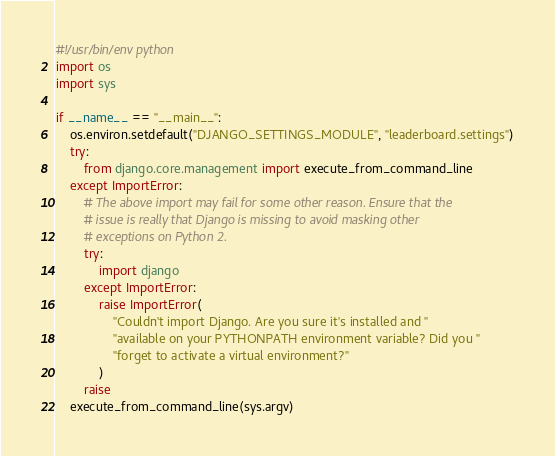<code> <loc_0><loc_0><loc_500><loc_500><_Python_>#!/usr/bin/env python
import os
import sys

if __name__ == "__main__":
    os.environ.setdefault("DJANGO_SETTINGS_MODULE", "leaderboard.settings")
    try:
        from django.core.management import execute_from_command_line
    except ImportError:
        # The above import may fail for some other reason. Ensure that the
        # issue is really that Django is missing to avoid masking other
        # exceptions on Python 2.
        try:
            import django
        except ImportError:
            raise ImportError(
                "Couldn't import Django. Are you sure it's installed and "
                "available on your PYTHONPATH environment variable? Did you "
                "forget to activate a virtual environment?"
            )
        raise
    execute_from_command_line(sys.argv)
</code> 